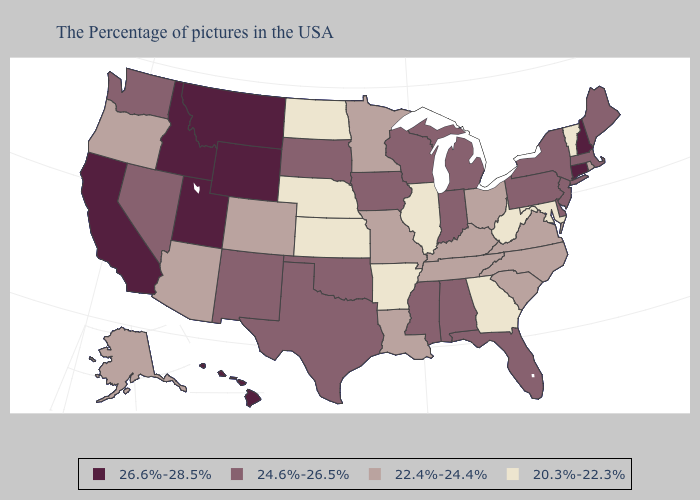Name the states that have a value in the range 22.4%-24.4%?
Quick response, please. Rhode Island, Virginia, North Carolina, South Carolina, Ohio, Kentucky, Tennessee, Louisiana, Missouri, Minnesota, Colorado, Arizona, Oregon, Alaska. Among the states that border Colorado , does Utah have the highest value?
Write a very short answer. Yes. Name the states that have a value in the range 24.6%-26.5%?
Give a very brief answer. Maine, Massachusetts, New York, New Jersey, Delaware, Pennsylvania, Florida, Michigan, Indiana, Alabama, Wisconsin, Mississippi, Iowa, Oklahoma, Texas, South Dakota, New Mexico, Nevada, Washington. Among the states that border Arkansas , does Oklahoma have the lowest value?
Keep it brief. No. Does Kansas have a higher value than Iowa?
Quick response, please. No. Does Idaho have the highest value in the USA?
Write a very short answer. Yes. Does North Dakota have a higher value than Michigan?
Be succinct. No. Does Indiana have the same value as Michigan?
Quick response, please. Yes. What is the value of West Virginia?
Be succinct. 20.3%-22.3%. What is the highest value in states that border New Jersey?
Answer briefly. 24.6%-26.5%. What is the lowest value in states that border North Dakota?
Concise answer only. 22.4%-24.4%. Name the states that have a value in the range 20.3%-22.3%?
Short answer required. Vermont, Maryland, West Virginia, Georgia, Illinois, Arkansas, Kansas, Nebraska, North Dakota. Does New Hampshire have the highest value in the Northeast?
Keep it brief. Yes. What is the value of California?
Concise answer only. 26.6%-28.5%. Name the states that have a value in the range 26.6%-28.5%?
Short answer required. New Hampshire, Connecticut, Wyoming, Utah, Montana, Idaho, California, Hawaii. 